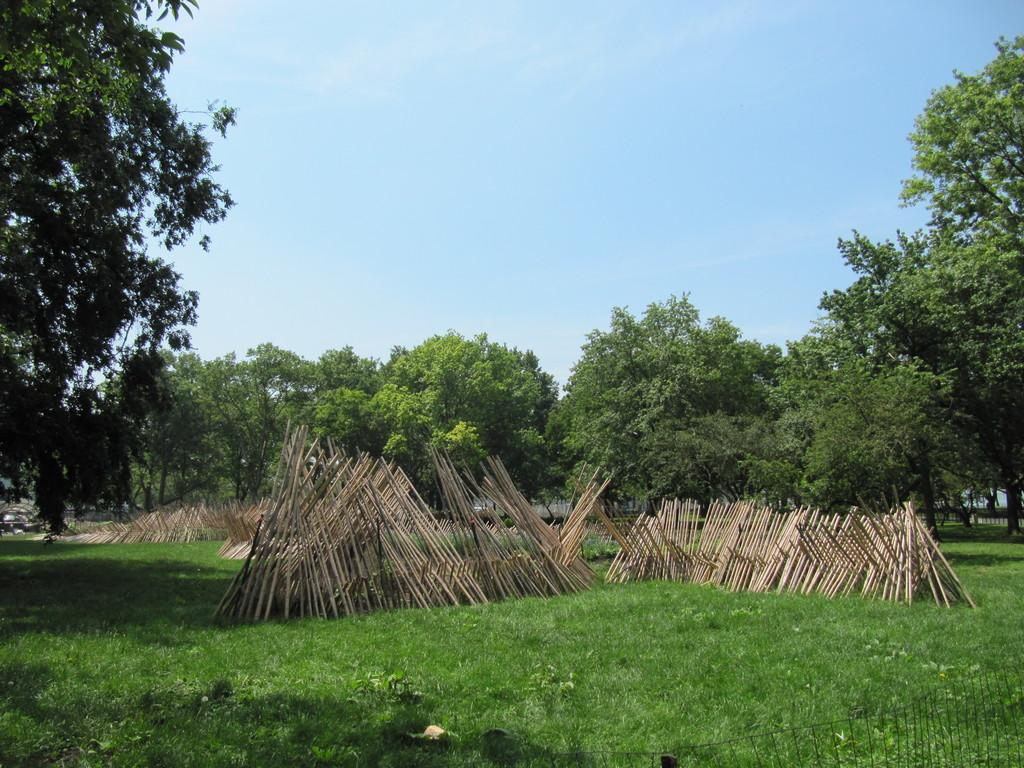What type of vegetation can be seen in the image? There are trees in the image. What objects are in the foreground of the image? There are sticks and a fence in the foreground of the image. What is visible at the top of the image? The sky is visible at the top of the image. What type of ground is present at the bottom of the image? Grass is present at the bottom of the image. What is the baby's reaction to the alley in the image? There is no baby or alley present in the image. What type of reaction can be seen from the creatures in the alley? There are no creatures or alley present in the image. 